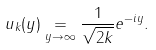Convert formula to latex. <formula><loc_0><loc_0><loc_500><loc_500>u _ { k } ( y ) \underset { y \rightarrow \infty } { = } \frac { 1 } { \sqrt { 2 k } } e ^ { - i y } .</formula> 